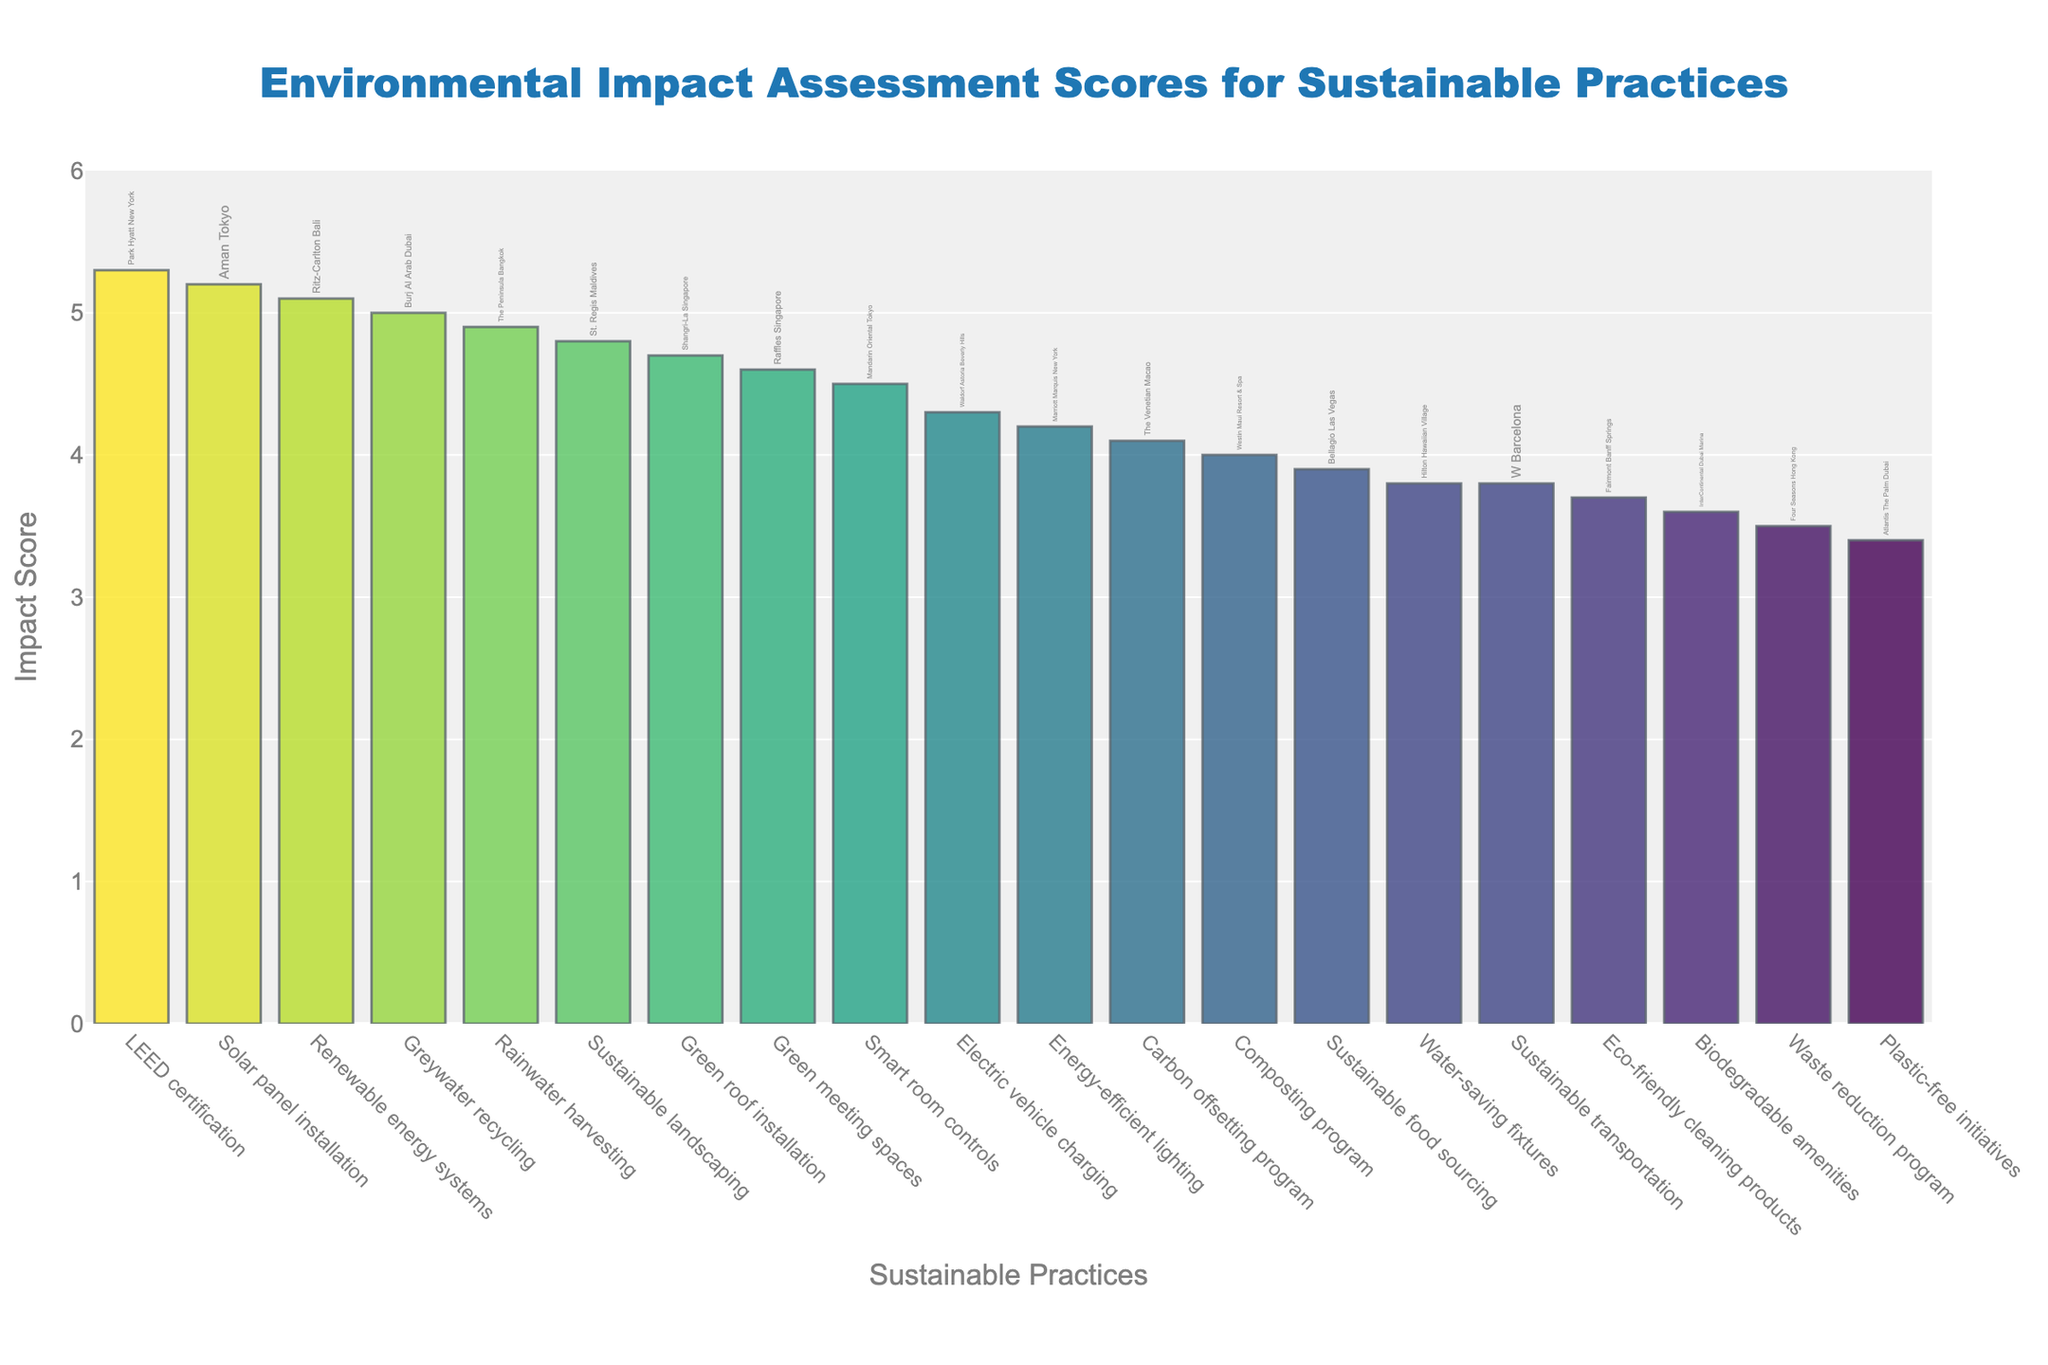How many different sustainable practices are represented in the plot? Count the number of bars in the plot, each corresponding to a distinct sustainable practice.
Answer: 20 Which sustainable practice has the highest impact score? Identify the tallest bar in the plot and observe the label associated with it.
Answer: LEED certification Which hotel property implemented the use of solar panels, and what is the impact score associated with that? Look for the label 'Solar panel installation' on the x-axis and read the associated hotel property and the length of the bar indicating the score.
Answer: Aman Tokyo, 5.2 Which hotel property achieved the lowest impact score and with which practice? Identify the shortest bar in the plot and observe the label and the associated hotel property.
Answer: Atlantis The Palm Dubai, Plastic-free initiatives Which sustainable practices have an impact score above 5.0? Identify the bars taller than the 5.0 mark and note their labels.
Answer: Renewable energy systems, LEED certification, Solar panel installation, Greywater recycling Compare the impact scores between Water-saving fixtures and Waste reduction program. Which one has the higher score? Observe the heights of the bars for Water-saving fixtures and Waste reduction program and compare them.
Answer: Water-saving fixtures How many sustainable practices have an impact score greater than 4.0 but less than 5.0? Count the number of bars whose tops fall between 4.0 and 5.0 on the y-axis.
Answer: 7 